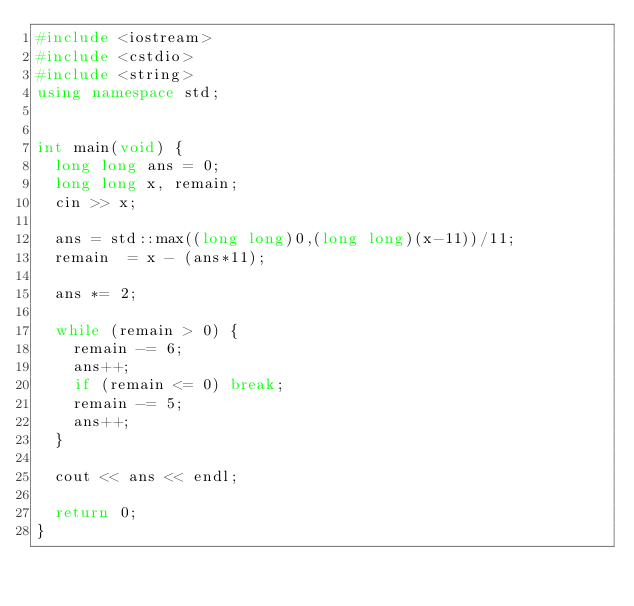Convert code to text. <code><loc_0><loc_0><loc_500><loc_500><_C++_>#include <iostream>
#include <cstdio>
#include <string>
using namespace std;


int main(void) {
	long long ans = 0;
	long long x, remain;
	cin >> x;

	ans = std::max((long long)0,(long long)(x-11))/11;
	remain  = x - (ans*11);

	ans *= 2;

	while (remain > 0) {
		remain -= 6;
		ans++;
		if (remain <= 0) break;
		remain -= 5;
		ans++;
	}

	cout << ans << endl;

	return 0;
}
</code> 